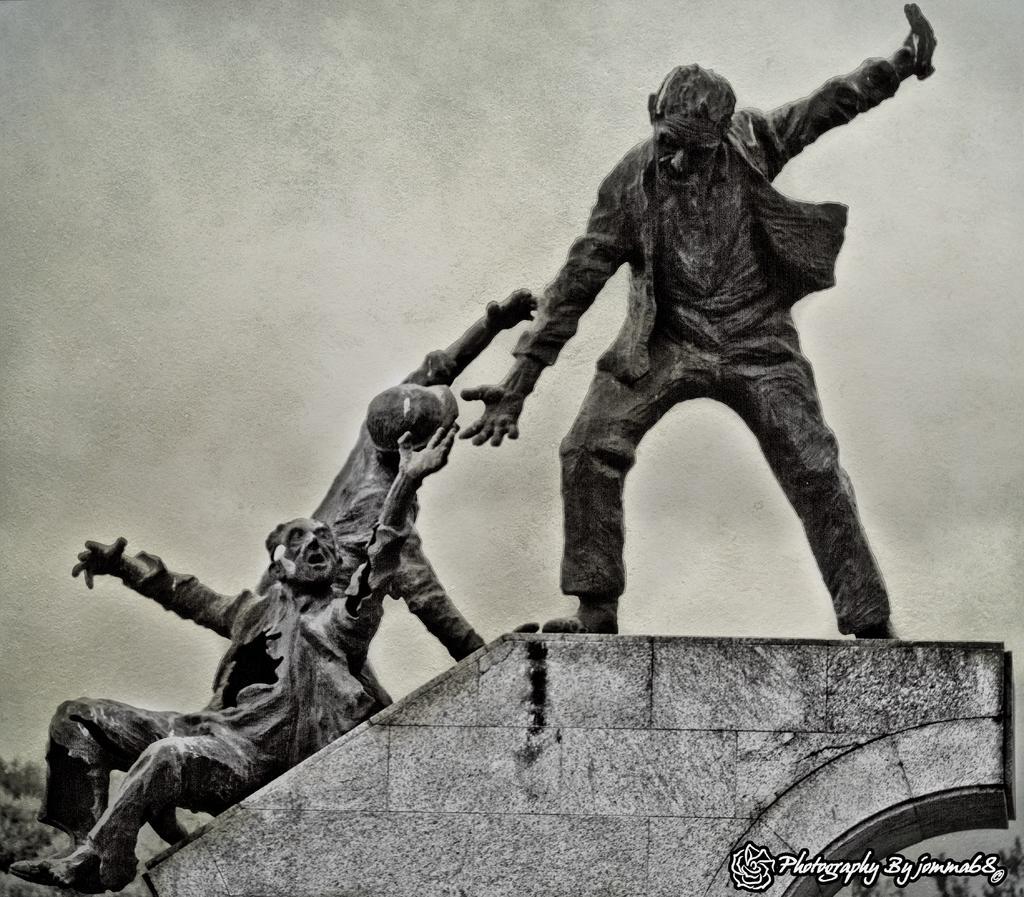Describe this image in one or two sentences. In the image we can see there are human statues standing on the wall of the building. The sky is clear and the image is in black and white colour. 